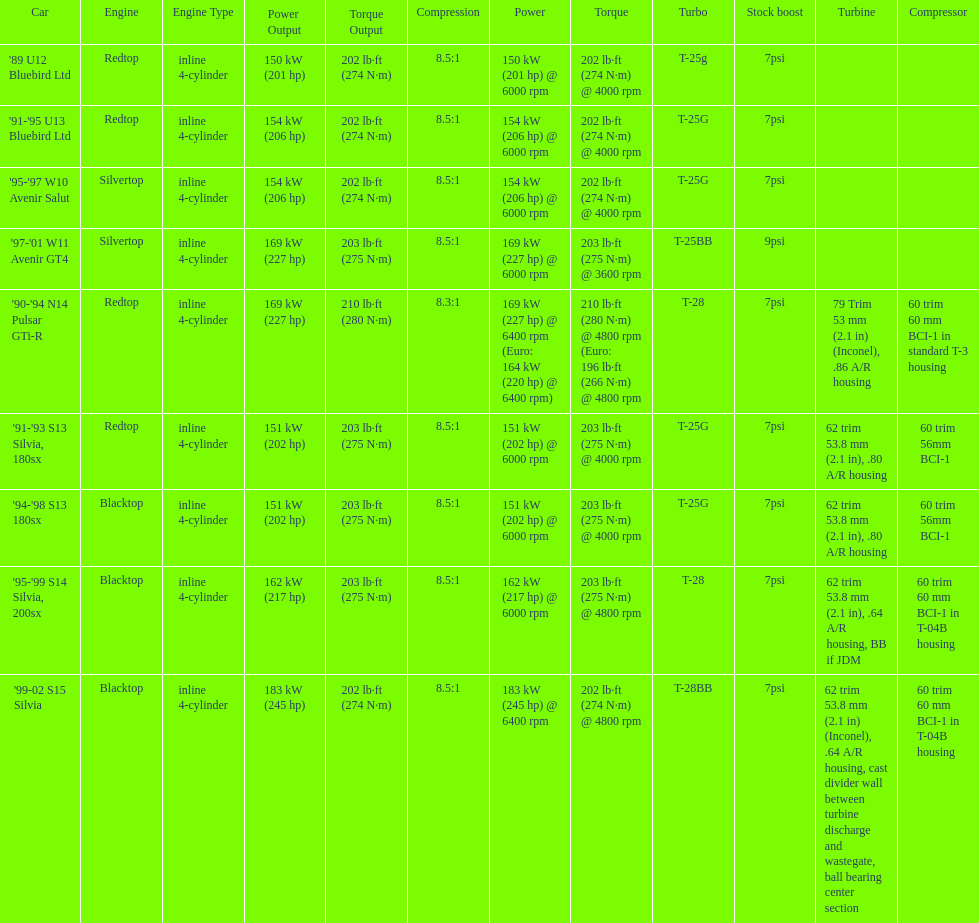What is his/her compression for the 90-94 n14 pulsar gti-r? 8.3:1. 